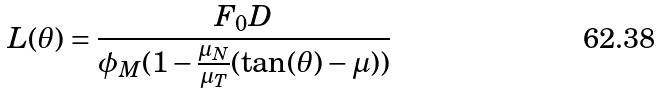Convert formula to latex. <formula><loc_0><loc_0><loc_500><loc_500>L ( \theta ) = \frac { F _ { 0 } D } { \phi _ { M } ( 1 - \frac { \mu _ { N } } { \mu _ { T } } ( \tan ( \theta ) - \mu ) ) }</formula> 